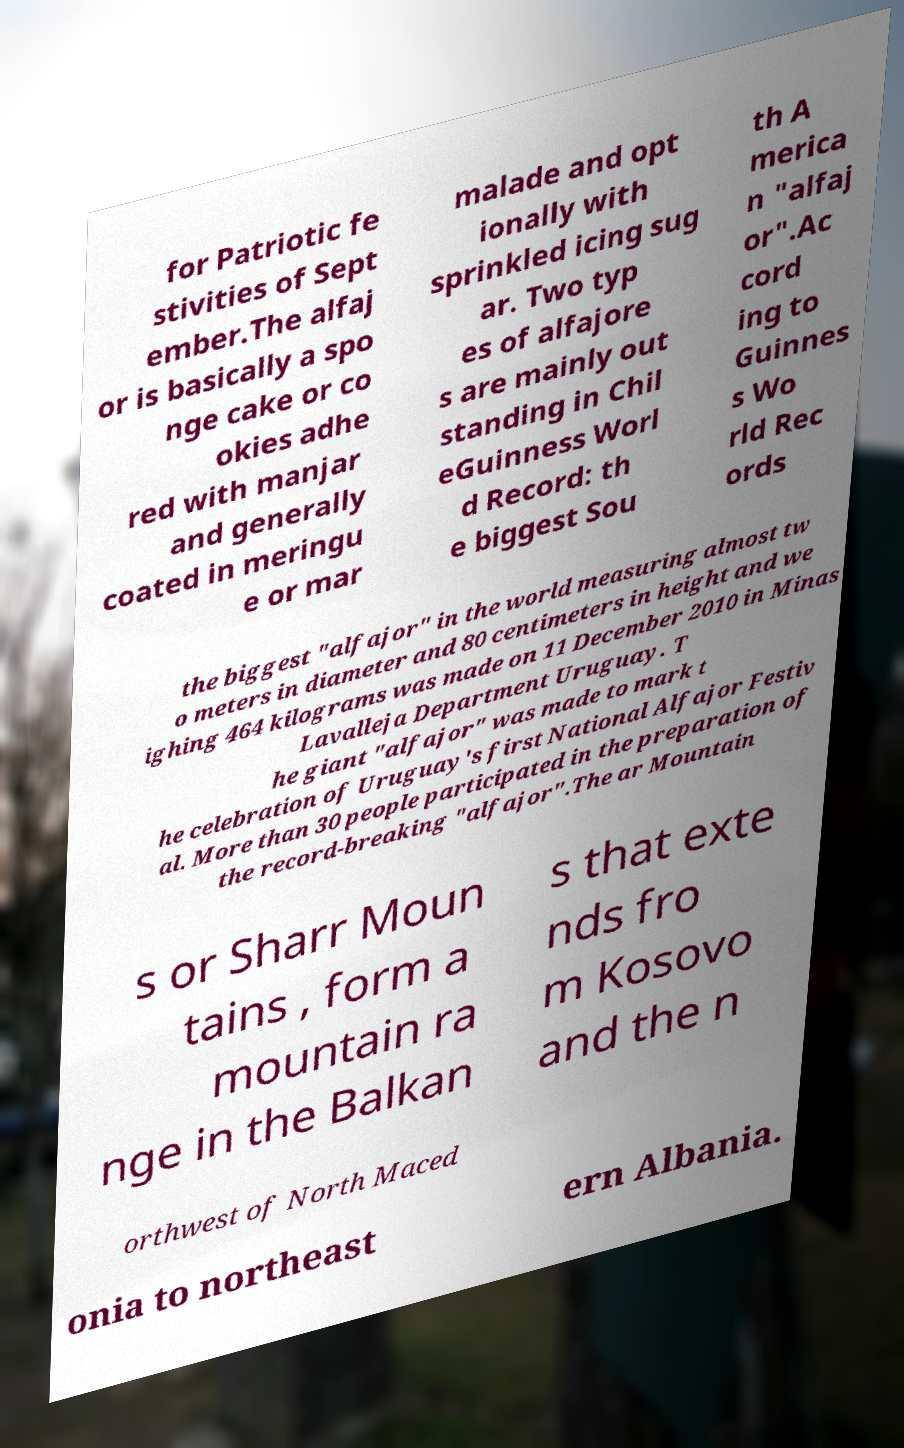I need the written content from this picture converted into text. Can you do that? for Patriotic fe stivities of Sept ember.The alfaj or is basically a spo nge cake or co okies adhe red with manjar and generally coated in meringu e or mar malade and opt ionally with sprinkled icing sug ar. Two typ es of alfajore s are mainly out standing in Chil eGuinness Worl d Record: th e biggest Sou th A merica n "alfaj or".Ac cord ing to Guinnes s Wo rld Rec ords the biggest "alfajor" in the world measuring almost tw o meters in diameter and 80 centimeters in height and we ighing 464 kilograms was made on 11 December 2010 in Minas Lavalleja Department Uruguay. T he giant "alfajor" was made to mark t he celebration of Uruguay's first National Alfajor Festiv al. More than 30 people participated in the preparation of the record-breaking "alfajor".The ar Mountain s or Sharr Moun tains , form a mountain ra nge in the Balkan s that exte nds fro m Kosovo and the n orthwest of North Maced onia to northeast ern Albania. 